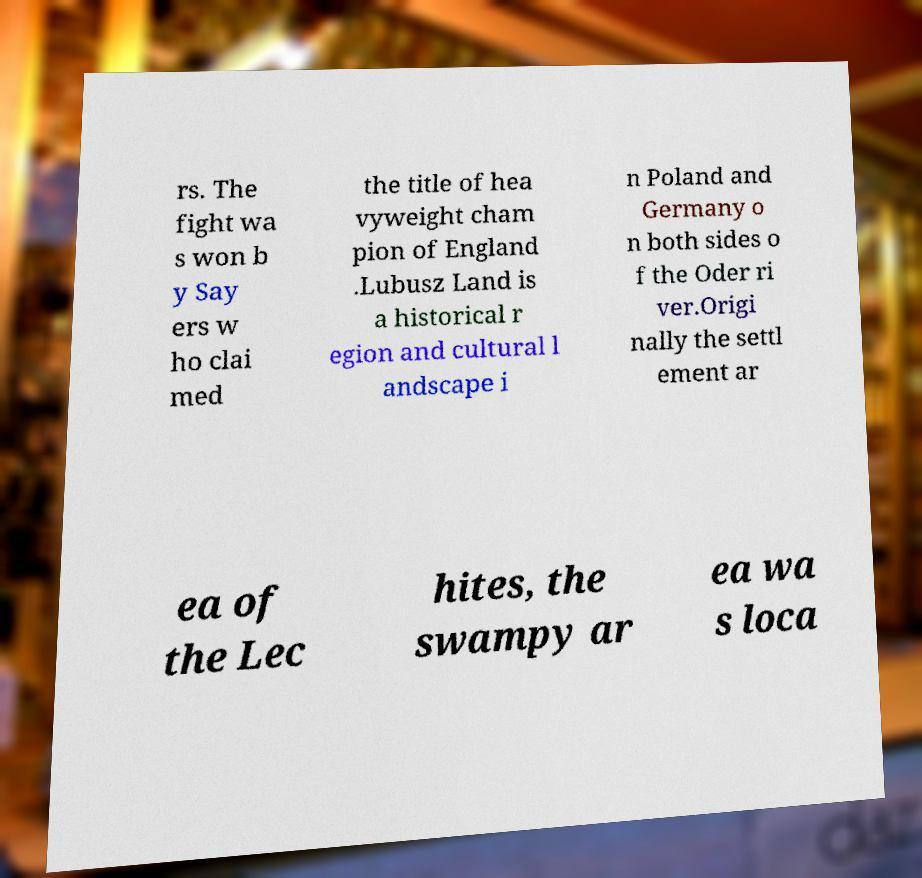Could you assist in decoding the text presented in this image and type it out clearly? rs. The fight wa s won b y Say ers w ho clai med the title of hea vyweight cham pion of England .Lubusz Land is a historical r egion and cultural l andscape i n Poland and Germany o n both sides o f the Oder ri ver.Origi nally the settl ement ar ea of the Lec hites, the swampy ar ea wa s loca 